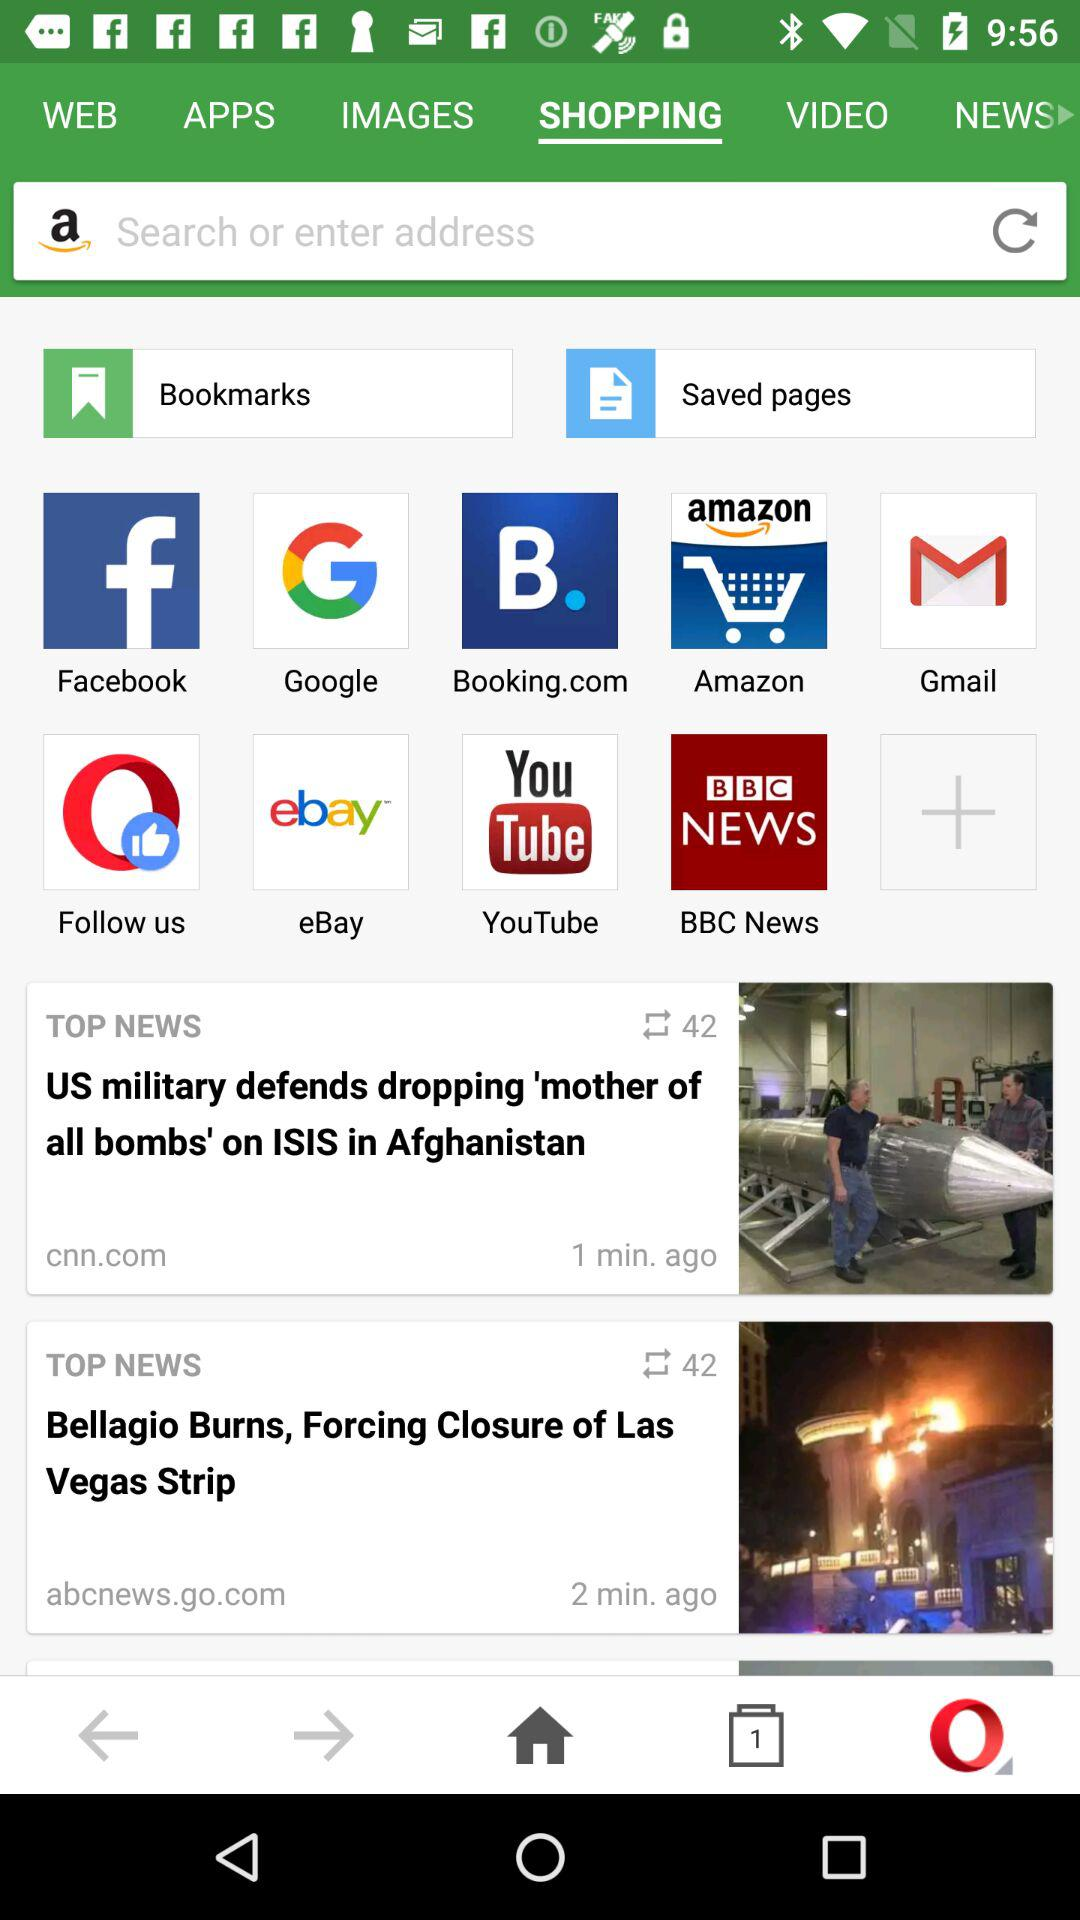How many items are in the top news section?
Answer the question using a single word or phrase. 2 